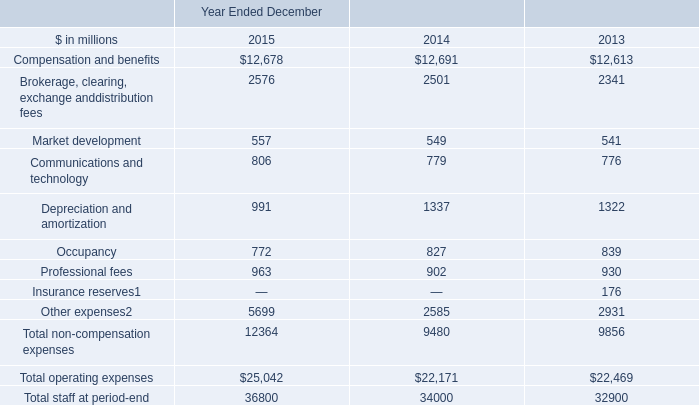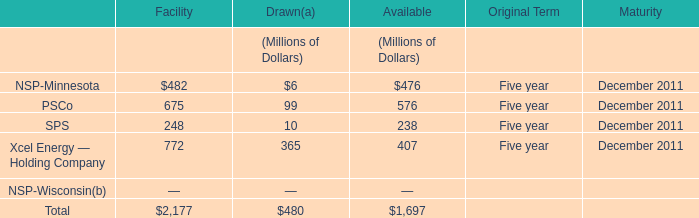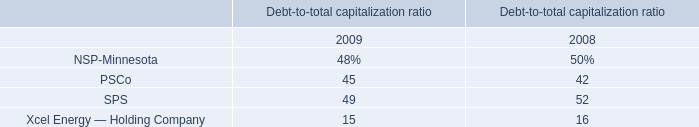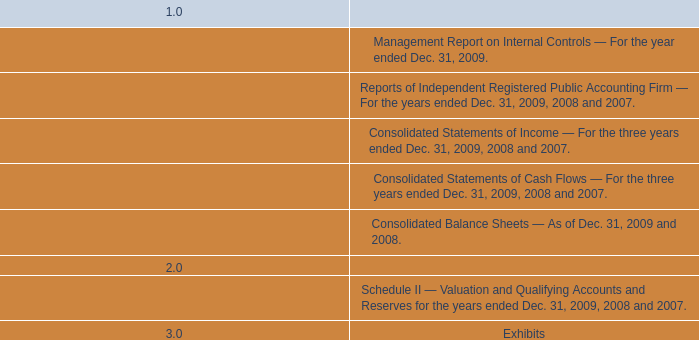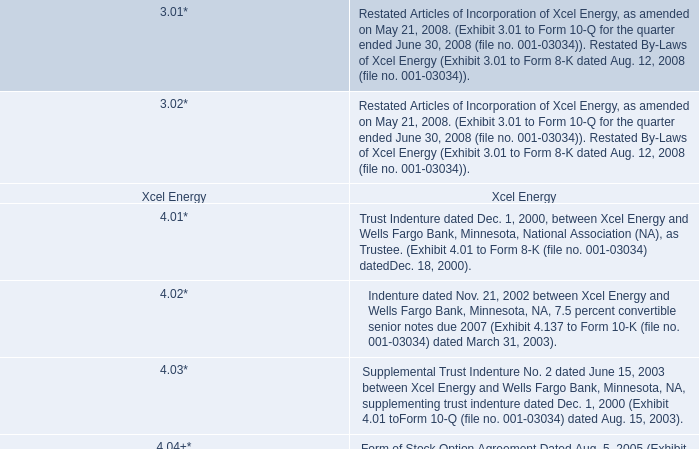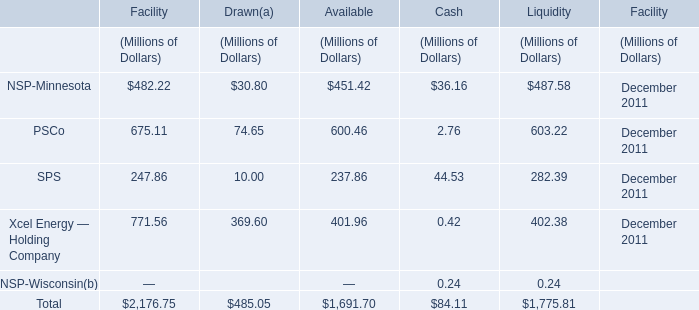What is the sum of NSP-Minnesota, PSCo and SPS for Available? (in Million) 
Computations: ((451.42 + 600.46) + 237.86)
Answer: 1289.74. 